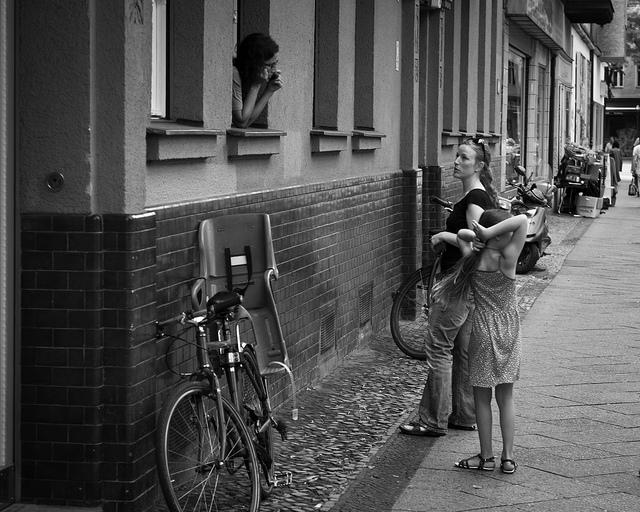The owner of the nearest Bicycle here has which role? parent 